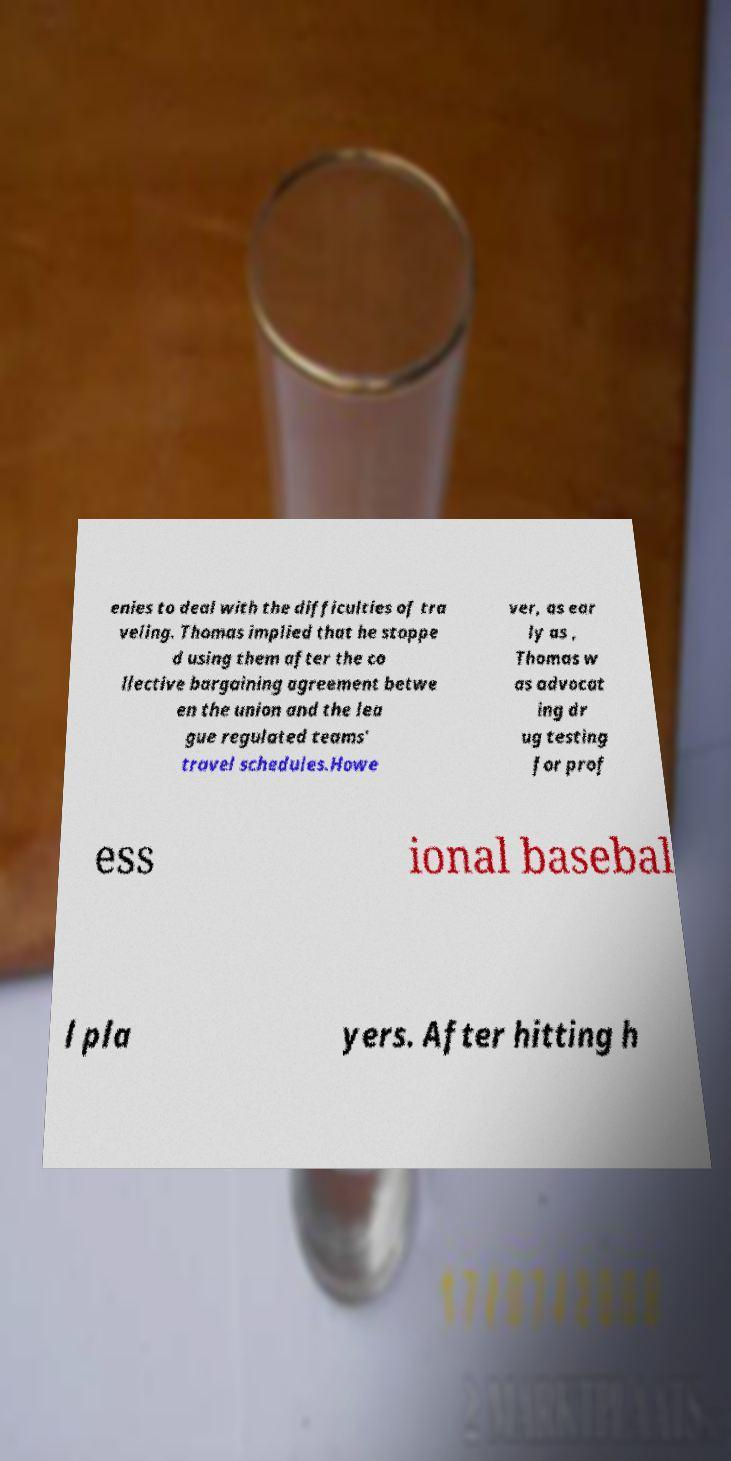Can you accurately transcribe the text from the provided image for me? enies to deal with the difficulties of tra veling. Thomas implied that he stoppe d using them after the co llective bargaining agreement betwe en the union and the lea gue regulated teams' travel schedules.Howe ver, as ear ly as , Thomas w as advocat ing dr ug testing for prof ess ional basebal l pla yers. After hitting h 